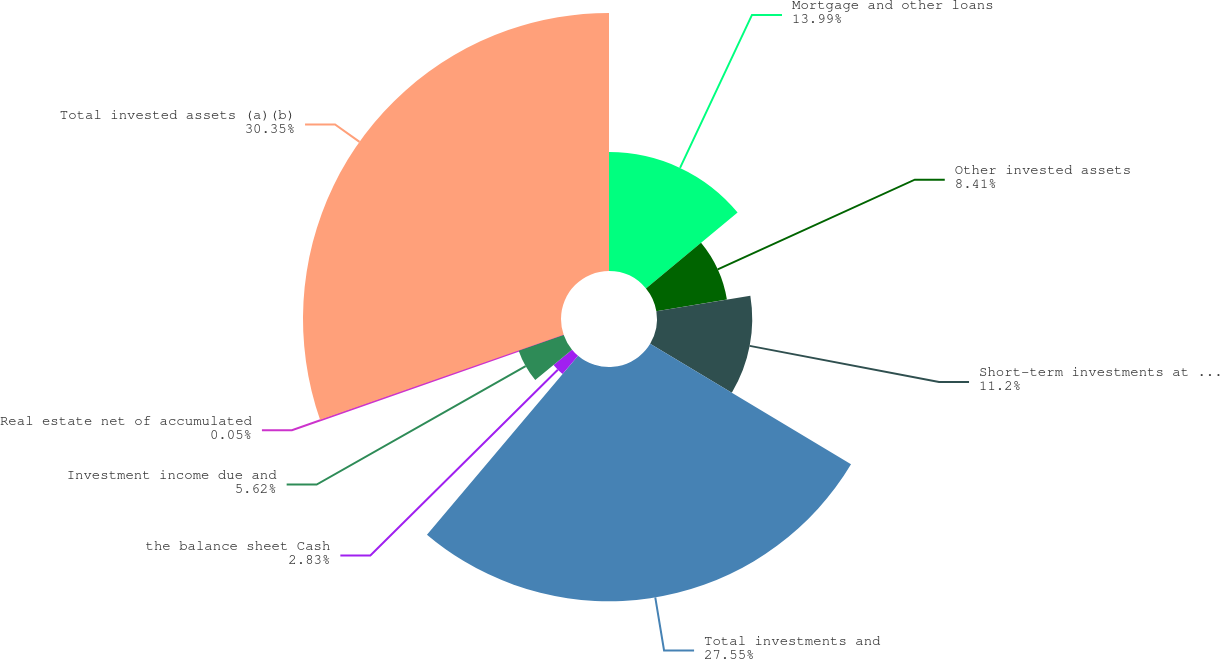Convert chart. <chart><loc_0><loc_0><loc_500><loc_500><pie_chart><fcel>Mortgage and other loans<fcel>Other invested assets<fcel>Short-term investments at cost<fcel>Total investments and<fcel>the balance sheet Cash<fcel>Investment income due and<fcel>Real estate net of accumulated<fcel>Total invested assets (a)(b)<nl><fcel>13.99%<fcel>8.41%<fcel>11.2%<fcel>27.55%<fcel>2.83%<fcel>5.62%<fcel>0.05%<fcel>30.34%<nl></chart> 